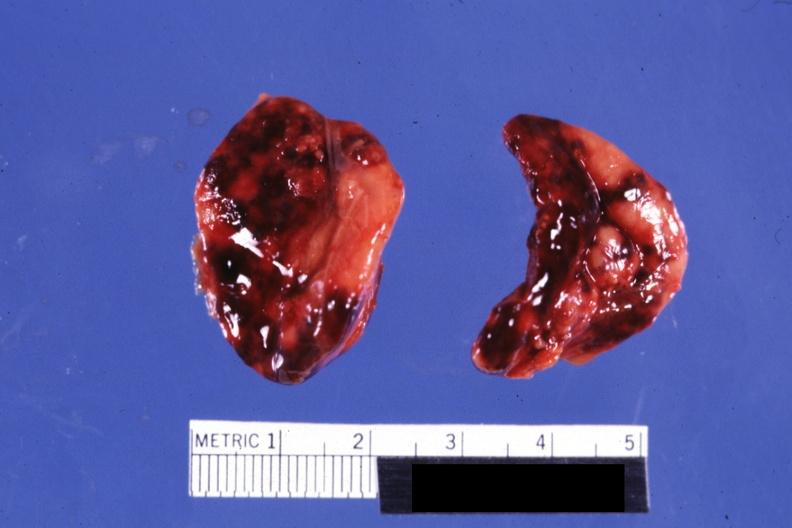does history look like placental abruption?
Answer the question using a single word or phrase. Yes 